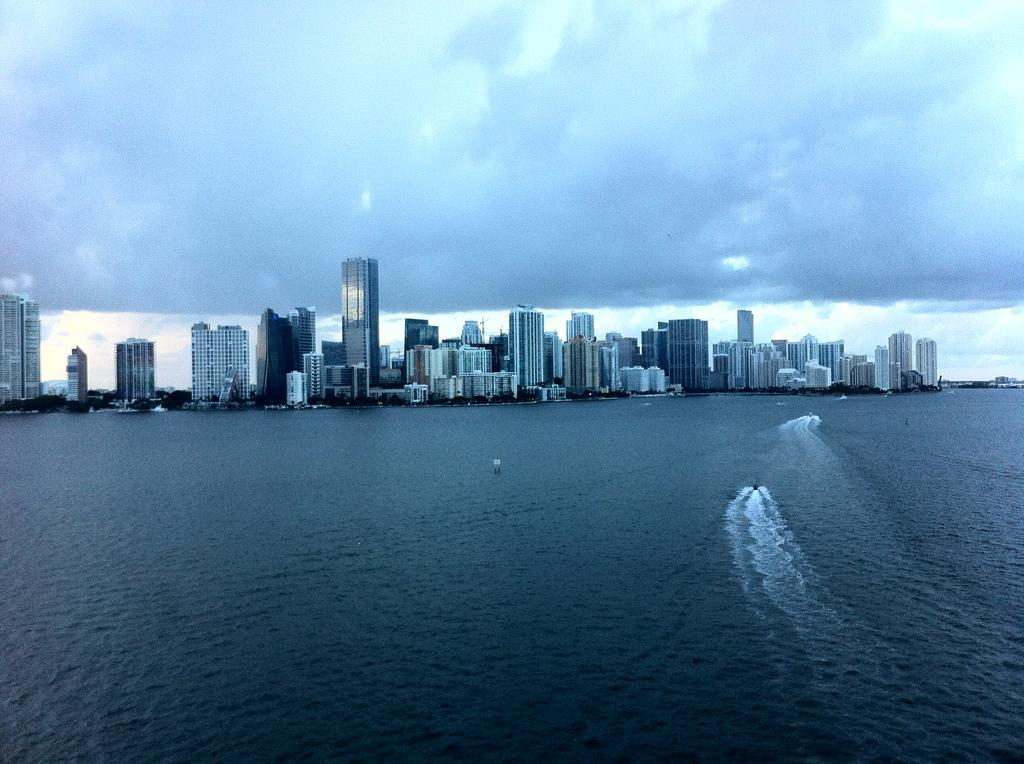What type of structures can be seen in the image? There are buildings in the image. What natural element is visible in the image? There is water visible in the image. What can be seen in the background of the image? The sky is visible in the background of the image. What role does the father play in the history of the buildings in the image? There is no mention of a father or any historical context in the image, so it is not possible to answer that question. 